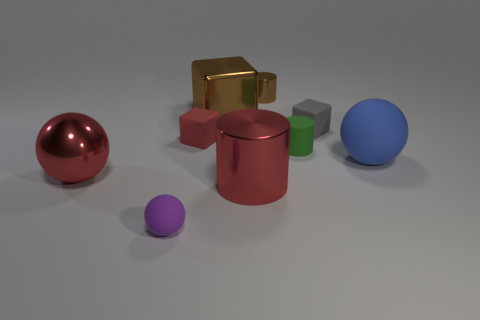What number of small red rubber objects are in front of the purple matte ball?
Your answer should be compact. 0. Is the number of big metal cylinders that are behind the tiny red cube less than the number of large brown metal spheres?
Ensure brevity in your answer.  No. What is the color of the tiny sphere?
Provide a succinct answer. Purple. Does the small matte block to the left of the big brown shiny thing have the same color as the large metal cylinder?
Your answer should be compact. Yes. What color is the other big metal object that is the same shape as the gray object?
Ensure brevity in your answer.  Brown. How many small things are either purple objects or metallic things?
Keep it short and to the point. 2. What size is the cylinder in front of the big blue thing?
Ensure brevity in your answer.  Large. Are there any small objects that have the same color as the large block?
Your answer should be compact. Yes. Do the metallic block and the tiny shiny cylinder have the same color?
Your answer should be compact. Yes. There is a small object that is the same color as the big cube; what shape is it?
Keep it short and to the point. Cylinder. 